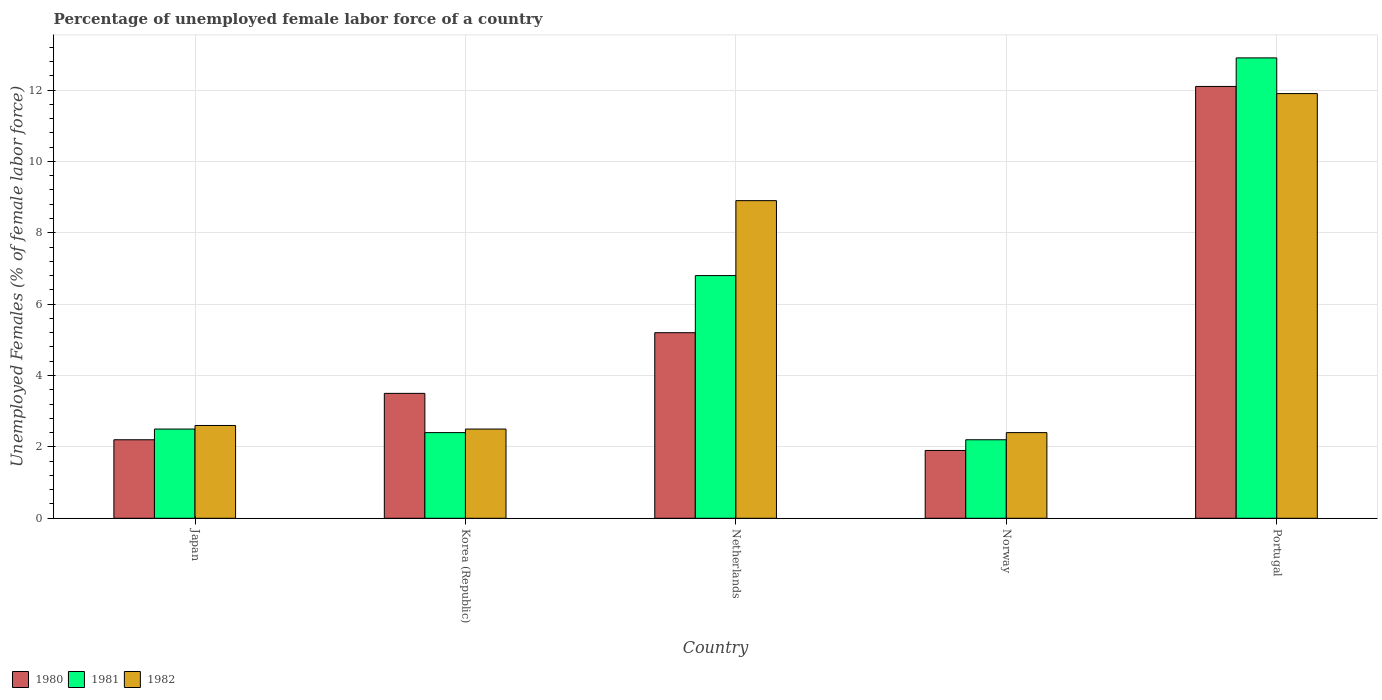How many different coloured bars are there?
Your answer should be compact. 3. Are the number of bars on each tick of the X-axis equal?
Give a very brief answer. Yes. How many bars are there on the 5th tick from the left?
Your answer should be very brief. 3. What is the label of the 1st group of bars from the left?
Provide a succinct answer. Japan. In how many cases, is the number of bars for a given country not equal to the number of legend labels?
Offer a terse response. 0. What is the percentage of unemployed female labor force in 1982 in Portugal?
Offer a very short reply. 11.9. Across all countries, what is the maximum percentage of unemployed female labor force in 1982?
Your answer should be very brief. 11.9. Across all countries, what is the minimum percentage of unemployed female labor force in 1980?
Offer a very short reply. 1.9. In which country was the percentage of unemployed female labor force in 1981 minimum?
Ensure brevity in your answer.  Norway. What is the total percentage of unemployed female labor force in 1982 in the graph?
Ensure brevity in your answer.  28.3. What is the difference between the percentage of unemployed female labor force in 1980 in Japan and that in Netherlands?
Make the answer very short. -3. What is the difference between the percentage of unemployed female labor force in 1981 in Norway and the percentage of unemployed female labor force in 1982 in Portugal?
Provide a succinct answer. -9.7. What is the average percentage of unemployed female labor force in 1982 per country?
Offer a terse response. 5.66. In how many countries, is the percentage of unemployed female labor force in 1980 greater than 1.2000000000000002 %?
Ensure brevity in your answer.  5. What is the ratio of the percentage of unemployed female labor force in 1980 in Korea (Republic) to that in Norway?
Your answer should be very brief. 1.84. What is the difference between the highest and the second highest percentage of unemployed female labor force in 1980?
Offer a terse response. -8.6. What is the difference between the highest and the lowest percentage of unemployed female labor force in 1980?
Offer a terse response. 10.2. In how many countries, is the percentage of unemployed female labor force in 1980 greater than the average percentage of unemployed female labor force in 1980 taken over all countries?
Make the answer very short. 2. Is the sum of the percentage of unemployed female labor force in 1982 in Korea (Republic) and Portugal greater than the maximum percentage of unemployed female labor force in 1980 across all countries?
Give a very brief answer. Yes. What does the 1st bar from the right in Norway represents?
Provide a short and direct response. 1982. Are all the bars in the graph horizontal?
Keep it short and to the point. No. What is the difference between two consecutive major ticks on the Y-axis?
Offer a very short reply. 2. Are the values on the major ticks of Y-axis written in scientific E-notation?
Offer a very short reply. No. Does the graph contain any zero values?
Keep it short and to the point. No. Does the graph contain grids?
Give a very brief answer. Yes. Where does the legend appear in the graph?
Offer a very short reply. Bottom left. How many legend labels are there?
Offer a very short reply. 3. What is the title of the graph?
Offer a very short reply. Percentage of unemployed female labor force of a country. Does "1961" appear as one of the legend labels in the graph?
Offer a very short reply. No. What is the label or title of the X-axis?
Make the answer very short. Country. What is the label or title of the Y-axis?
Offer a terse response. Unemployed Females (% of female labor force). What is the Unemployed Females (% of female labor force) in 1980 in Japan?
Keep it short and to the point. 2.2. What is the Unemployed Females (% of female labor force) in 1981 in Japan?
Give a very brief answer. 2.5. What is the Unemployed Females (% of female labor force) of 1982 in Japan?
Your answer should be compact. 2.6. What is the Unemployed Females (% of female labor force) of 1981 in Korea (Republic)?
Provide a short and direct response. 2.4. What is the Unemployed Females (% of female labor force) in 1982 in Korea (Republic)?
Offer a terse response. 2.5. What is the Unemployed Females (% of female labor force) in 1980 in Netherlands?
Your answer should be compact. 5.2. What is the Unemployed Females (% of female labor force) in 1981 in Netherlands?
Give a very brief answer. 6.8. What is the Unemployed Females (% of female labor force) of 1982 in Netherlands?
Keep it short and to the point. 8.9. What is the Unemployed Females (% of female labor force) in 1980 in Norway?
Provide a short and direct response. 1.9. What is the Unemployed Females (% of female labor force) of 1981 in Norway?
Offer a terse response. 2.2. What is the Unemployed Females (% of female labor force) of 1982 in Norway?
Keep it short and to the point. 2.4. What is the Unemployed Females (% of female labor force) of 1980 in Portugal?
Ensure brevity in your answer.  12.1. What is the Unemployed Females (% of female labor force) of 1981 in Portugal?
Offer a terse response. 12.9. What is the Unemployed Females (% of female labor force) in 1982 in Portugal?
Give a very brief answer. 11.9. Across all countries, what is the maximum Unemployed Females (% of female labor force) of 1980?
Make the answer very short. 12.1. Across all countries, what is the maximum Unemployed Females (% of female labor force) of 1981?
Ensure brevity in your answer.  12.9. Across all countries, what is the maximum Unemployed Females (% of female labor force) of 1982?
Ensure brevity in your answer.  11.9. Across all countries, what is the minimum Unemployed Females (% of female labor force) in 1980?
Keep it short and to the point. 1.9. Across all countries, what is the minimum Unemployed Females (% of female labor force) in 1981?
Your answer should be very brief. 2.2. Across all countries, what is the minimum Unemployed Females (% of female labor force) in 1982?
Provide a short and direct response. 2.4. What is the total Unemployed Females (% of female labor force) in 1980 in the graph?
Ensure brevity in your answer.  24.9. What is the total Unemployed Females (% of female labor force) in 1981 in the graph?
Make the answer very short. 26.8. What is the total Unemployed Females (% of female labor force) in 1982 in the graph?
Your answer should be very brief. 28.3. What is the difference between the Unemployed Females (% of female labor force) of 1980 in Japan and that in Korea (Republic)?
Your answer should be very brief. -1.3. What is the difference between the Unemployed Females (% of female labor force) of 1982 in Japan and that in Netherlands?
Give a very brief answer. -6.3. What is the difference between the Unemployed Females (% of female labor force) of 1980 in Japan and that in Norway?
Offer a terse response. 0.3. What is the difference between the Unemployed Females (% of female labor force) in 1982 in Japan and that in Norway?
Ensure brevity in your answer.  0.2. What is the difference between the Unemployed Females (% of female labor force) of 1982 in Japan and that in Portugal?
Offer a very short reply. -9.3. What is the difference between the Unemployed Females (% of female labor force) in 1980 in Korea (Republic) and that in Netherlands?
Make the answer very short. -1.7. What is the difference between the Unemployed Females (% of female labor force) of 1981 in Korea (Republic) and that in Netherlands?
Give a very brief answer. -4.4. What is the difference between the Unemployed Females (% of female labor force) of 1981 in Korea (Republic) and that in Norway?
Ensure brevity in your answer.  0.2. What is the difference between the Unemployed Females (% of female labor force) in 1980 in Korea (Republic) and that in Portugal?
Offer a very short reply. -8.6. What is the difference between the Unemployed Females (% of female labor force) of 1982 in Korea (Republic) and that in Portugal?
Your response must be concise. -9.4. What is the difference between the Unemployed Females (% of female labor force) of 1980 in Netherlands and that in Norway?
Offer a terse response. 3.3. What is the difference between the Unemployed Females (% of female labor force) in 1982 in Netherlands and that in Norway?
Ensure brevity in your answer.  6.5. What is the difference between the Unemployed Females (% of female labor force) in 1982 in Netherlands and that in Portugal?
Provide a short and direct response. -3. What is the difference between the Unemployed Females (% of female labor force) of 1980 in Norway and that in Portugal?
Offer a very short reply. -10.2. What is the difference between the Unemployed Females (% of female labor force) in 1981 in Norway and that in Portugal?
Give a very brief answer. -10.7. What is the difference between the Unemployed Females (% of female labor force) in 1982 in Norway and that in Portugal?
Your response must be concise. -9.5. What is the difference between the Unemployed Females (% of female labor force) in 1980 in Japan and the Unemployed Females (% of female labor force) in 1981 in Netherlands?
Ensure brevity in your answer.  -4.6. What is the difference between the Unemployed Females (% of female labor force) of 1980 in Japan and the Unemployed Females (% of female labor force) of 1982 in Netherlands?
Ensure brevity in your answer.  -6.7. What is the difference between the Unemployed Females (% of female labor force) of 1981 in Japan and the Unemployed Females (% of female labor force) of 1982 in Netherlands?
Keep it short and to the point. -6.4. What is the difference between the Unemployed Females (% of female labor force) in 1981 in Japan and the Unemployed Females (% of female labor force) in 1982 in Norway?
Make the answer very short. 0.1. What is the difference between the Unemployed Females (% of female labor force) of 1981 in Japan and the Unemployed Females (% of female labor force) of 1982 in Portugal?
Keep it short and to the point. -9.4. What is the difference between the Unemployed Females (% of female labor force) of 1980 in Korea (Republic) and the Unemployed Females (% of female labor force) of 1981 in Netherlands?
Offer a terse response. -3.3. What is the difference between the Unemployed Females (% of female labor force) in 1981 in Korea (Republic) and the Unemployed Females (% of female labor force) in 1982 in Norway?
Ensure brevity in your answer.  0. What is the difference between the Unemployed Females (% of female labor force) in 1981 in Korea (Republic) and the Unemployed Females (% of female labor force) in 1982 in Portugal?
Offer a very short reply. -9.5. What is the difference between the Unemployed Females (% of female labor force) in 1980 in Netherlands and the Unemployed Females (% of female labor force) in 1982 in Norway?
Your response must be concise. 2.8. What is the difference between the Unemployed Females (% of female labor force) in 1981 in Netherlands and the Unemployed Females (% of female labor force) in 1982 in Norway?
Your answer should be compact. 4.4. What is the difference between the Unemployed Females (% of female labor force) of 1980 in Netherlands and the Unemployed Females (% of female labor force) of 1982 in Portugal?
Make the answer very short. -6.7. What is the difference between the Unemployed Females (% of female labor force) in 1981 in Netherlands and the Unemployed Females (% of female labor force) in 1982 in Portugal?
Give a very brief answer. -5.1. What is the difference between the Unemployed Females (% of female labor force) in 1980 in Norway and the Unemployed Females (% of female labor force) in 1981 in Portugal?
Provide a succinct answer. -11. What is the average Unemployed Females (% of female labor force) of 1980 per country?
Provide a short and direct response. 4.98. What is the average Unemployed Females (% of female labor force) of 1981 per country?
Your answer should be compact. 5.36. What is the average Unemployed Females (% of female labor force) in 1982 per country?
Offer a terse response. 5.66. What is the difference between the Unemployed Females (% of female labor force) in 1980 and Unemployed Females (% of female labor force) in 1981 in Japan?
Your answer should be very brief. -0.3. What is the difference between the Unemployed Females (% of female labor force) in 1980 and Unemployed Females (% of female labor force) in 1982 in Japan?
Make the answer very short. -0.4. What is the difference between the Unemployed Females (% of female labor force) in 1980 and Unemployed Females (% of female labor force) in 1981 in Netherlands?
Keep it short and to the point. -1.6. What is the difference between the Unemployed Females (% of female labor force) of 1980 and Unemployed Females (% of female labor force) of 1982 in Netherlands?
Provide a succinct answer. -3.7. What is the difference between the Unemployed Females (% of female labor force) of 1981 and Unemployed Females (% of female labor force) of 1982 in Netherlands?
Offer a terse response. -2.1. What is the difference between the Unemployed Females (% of female labor force) in 1980 and Unemployed Females (% of female labor force) in 1981 in Norway?
Keep it short and to the point. -0.3. What is the difference between the Unemployed Females (% of female labor force) of 1981 and Unemployed Females (% of female labor force) of 1982 in Norway?
Your response must be concise. -0.2. What is the difference between the Unemployed Females (% of female labor force) of 1980 and Unemployed Females (% of female labor force) of 1981 in Portugal?
Your answer should be compact. -0.8. What is the difference between the Unemployed Females (% of female labor force) in 1980 and Unemployed Females (% of female labor force) in 1982 in Portugal?
Keep it short and to the point. 0.2. What is the difference between the Unemployed Females (% of female labor force) in 1981 and Unemployed Females (% of female labor force) in 1982 in Portugal?
Make the answer very short. 1. What is the ratio of the Unemployed Females (% of female labor force) of 1980 in Japan to that in Korea (Republic)?
Keep it short and to the point. 0.63. What is the ratio of the Unemployed Females (% of female labor force) of 1981 in Japan to that in Korea (Republic)?
Ensure brevity in your answer.  1.04. What is the ratio of the Unemployed Females (% of female labor force) of 1980 in Japan to that in Netherlands?
Offer a very short reply. 0.42. What is the ratio of the Unemployed Females (% of female labor force) of 1981 in Japan to that in Netherlands?
Provide a succinct answer. 0.37. What is the ratio of the Unemployed Females (% of female labor force) in 1982 in Japan to that in Netherlands?
Your answer should be very brief. 0.29. What is the ratio of the Unemployed Females (% of female labor force) in 1980 in Japan to that in Norway?
Offer a terse response. 1.16. What is the ratio of the Unemployed Females (% of female labor force) in 1981 in Japan to that in Norway?
Keep it short and to the point. 1.14. What is the ratio of the Unemployed Females (% of female labor force) of 1982 in Japan to that in Norway?
Ensure brevity in your answer.  1.08. What is the ratio of the Unemployed Females (% of female labor force) in 1980 in Japan to that in Portugal?
Offer a terse response. 0.18. What is the ratio of the Unemployed Females (% of female labor force) of 1981 in Japan to that in Portugal?
Offer a terse response. 0.19. What is the ratio of the Unemployed Females (% of female labor force) of 1982 in Japan to that in Portugal?
Your answer should be compact. 0.22. What is the ratio of the Unemployed Females (% of female labor force) of 1980 in Korea (Republic) to that in Netherlands?
Provide a succinct answer. 0.67. What is the ratio of the Unemployed Females (% of female labor force) in 1981 in Korea (Republic) to that in Netherlands?
Offer a terse response. 0.35. What is the ratio of the Unemployed Females (% of female labor force) in 1982 in Korea (Republic) to that in Netherlands?
Your response must be concise. 0.28. What is the ratio of the Unemployed Females (% of female labor force) of 1980 in Korea (Republic) to that in Norway?
Provide a short and direct response. 1.84. What is the ratio of the Unemployed Females (% of female labor force) in 1982 in Korea (Republic) to that in Norway?
Give a very brief answer. 1.04. What is the ratio of the Unemployed Females (% of female labor force) in 1980 in Korea (Republic) to that in Portugal?
Give a very brief answer. 0.29. What is the ratio of the Unemployed Females (% of female labor force) of 1981 in Korea (Republic) to that in Portugal?
Offer a terse response. 0.19. What is the ratio of the Unemployed Females (% of female labor force) in 1982 in Korea (Republic) to that in Portugal?
Your answer should be very brief. 0.21. What is the ratio of the Unemployed Females (% of female labor force) of 1980 in Netherlands to that in Norway?
Your answer should be compact. 2.74. What is the ratio of the Unemployed Females (% of female labor force) of 1981 in Netherlands to that in Norway?
Offer a very short reply. 3.09. What is the ratio of the Unemployed Females (% of female labor force) of 1982 in Netherlands to that in Norway?
Give a very brief answer. 3.71. What is the ratio of the Unemployed Females (% of female labor force) of 1980 in Netherlands to that in Portugal?
Offer a terse response. 0.43. What is the ratio of the Unemployed Females (% of female labor force) of 1981 in Netherlands to that in Portugal?
Provide a succinct answer. 0.53. What is the ratio of the Unemployed Females (% of female labor force) in 1982 in Netherlands to that in Portugal?
Offer a very short reply. 0.75. What is the ratio of the Unemployed Females (% of female labor force) of 1980 in Norway to that in Portugal?
Provide a succinct answer. 0.16. What is the ratio of the Unemployed Females (% of female labor force) of 1981 in Norway to that in Portugal?
Give a very brief answer. 0.17. What is the ratio of the Unemployed Females (% of female labor force) in 1982 in Norway to that in Portugal?
Your response must be concise. 0.2. What is the difference between the highest and the second highest Unemployed Females (% of female labor force) of 1980?
Offer a terse response. 6.9. What is the difference between the highest and the second highest Unemployed Females (% of female labor force) in 1981?
Offer a very short reply. 6.1. What is the difference between the highest and the second highest Unemployed Females (% of female labor force) in 1982?
Make the answer very short. 3. What is the difference between the highest and the lowest Unemployed Females (% of female labor force) in 1981?
Ensure brevity in your answer.  10.7. 